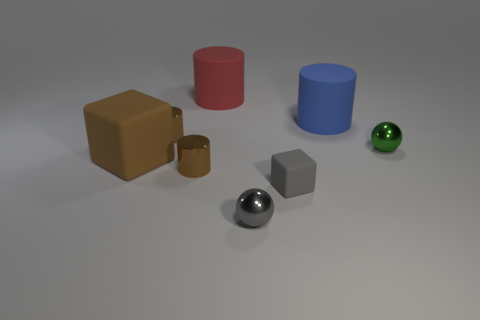Do the brown rubber object and the thing that is in front of the tiny rubber object have the same size? Upon visual examination, the brown rubber object appears significantly larger than the spherical object placed in front of it, implying that they do not share the same size. 